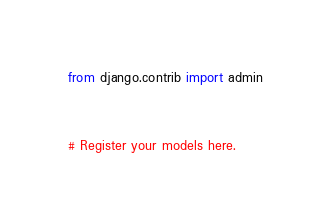<code> <loc_0><loc_0><loc_500><loc_500><_Python_>from django.contrib import admin



# Register your models here.

</code> 